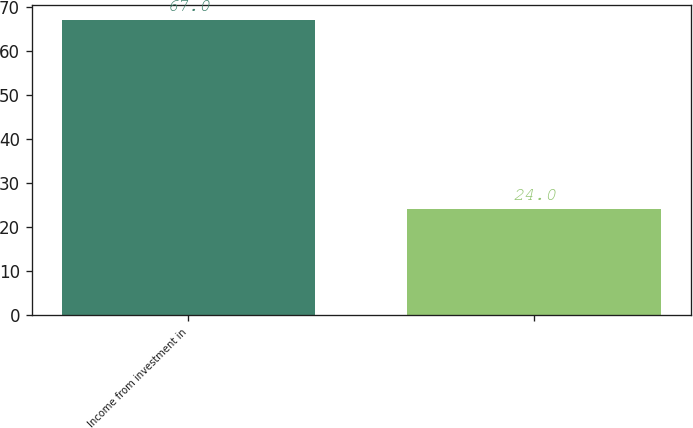<chart> <loc_0><loc_0><loc_500><loc_500><bar_chart><fcel>Income from investment in<fcel>Unnamed: 1<nl><fcel>67<fcel>24<nl></chart> 